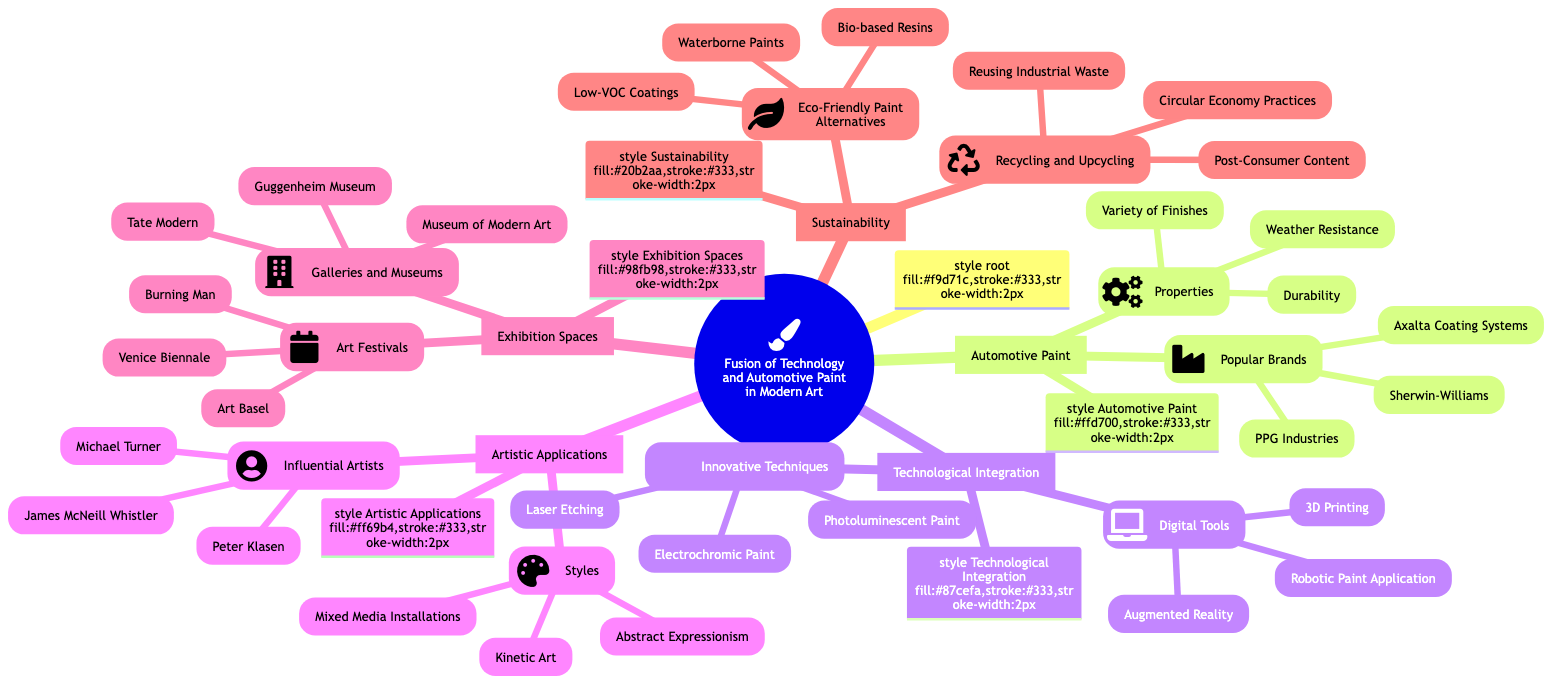What are the three properties of automotive paint listed? The diagram indicates "Durability," "Weather Resistance," and "Variety of Finishes" as the properties of automotive paint under the "Automotive Paint" subtopic.
Answer: Durability, Weather Resistance, Variety of Finishes Which brand is associated with automotive paint? According to the subtopic "Popular Brands" in "Automotive Paint," the brands listed include "PPG Industries," "Sherwin-Williams," and "Axalta Coating Systems."
Answer: PPG Industries How many innovative techniques are mentioned under Technological Integration? The "Innovative Techniques" subtopic lists three techniques: "Laser Etching," "Electrochromic Paint," and "Photoluminescent Paint." Therefore, counting these yields a total of three techniques.
Answer: 3 What is one of the artistic styles related to automotive paint? The diagram lists "Abstract Expressionism," "Kinetic Art," and "Mixed Media Installations" under the "Styles" in "Artistic Applications," so any of these would be correct.
Answer: Abstract Expressionism Which eco-friendly paint alternative is listed? Under the "Eco-Friendly Paint Alternatives" section of "Sustainability," the options include "Waterborne Paints," "Low-VOC Coatings," and "Bio-based Resins." Thus, any mentioned alternative is acceptable.
Answer: Waterborne Paints What connection exists between exhibition spaces and museums? The diagram shows that "Galleries and Museums," which includes "Museum of Modern Art," "Tate Modern," and "Guggenheim Museum," is a subcategory under "Exhibition Spaces" indicating a clear relationship.
Answer: Museums How does the use of digital tools relate to artistic applications? The diagram shows that "Digital Tools," such as "3D Printing" and "Augmented Reality," fall under "Technological Integration," which contributes to the "Artistic Applications" category, suggesting a technological influence on modern art.
Answer: Influence on modern art How many influential artists are listed in the "Influential Artists" section? The section identifies three artists: "Michael Turner," "James McNeill Whistler," and "Peter Klasen." Therefore, a count of the names shows there are three influential artists mentioned.
Answer: 3 